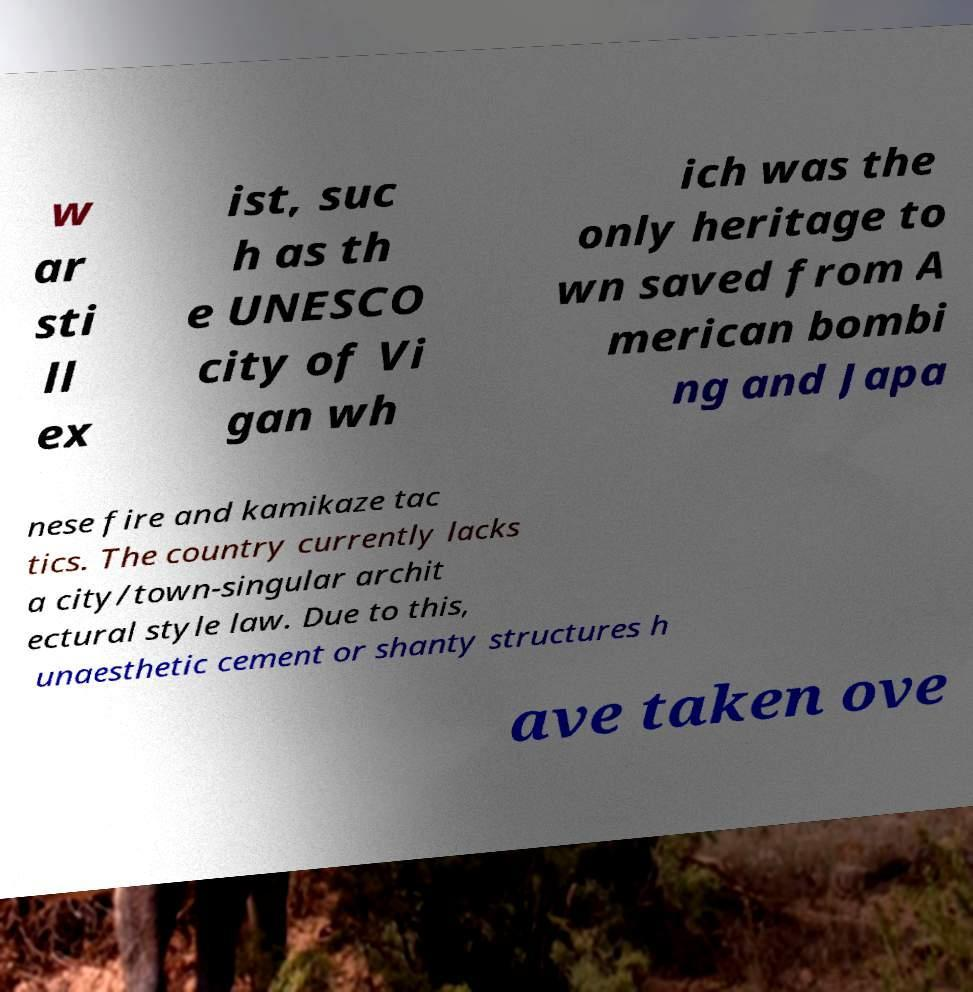Can you accurately transcribe the text from the provided image for me? w ar sti ll ex ist, suc h as th e UNESCO city of Vi gan wh ich was the only heritage to wn saved from A merican bombi ng and Japa nese fire and kamikaze tac tics. The country currently lacks a city/town-singular archit ectural style law. Due to this, unaesthetic cement or shanty structures h ave taken ove 